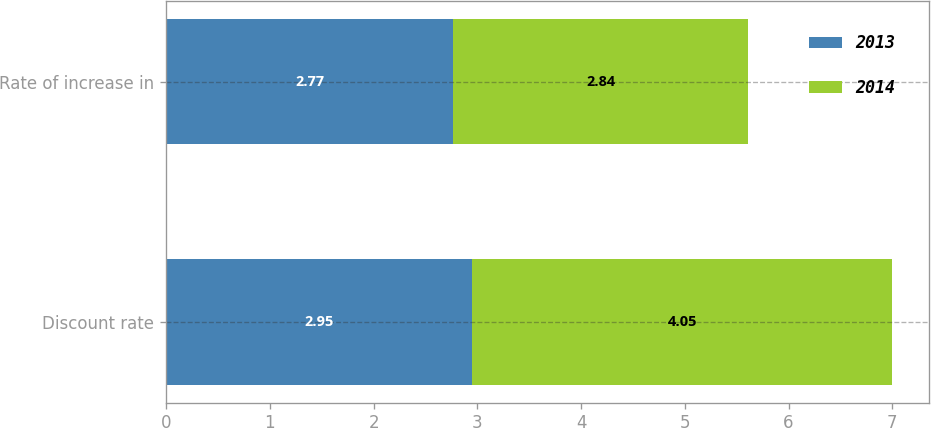Convert chart to OTSL. <chart><loc_0><loc_0><loc_500><loc_500><stacked_bar_chart><ecel><fcel>Discount rate<fcel>Rate of increase in<nl><fcel>2013<fcel>2.95<fcel>2.77<nl><fcel>2014<fcel>4.05<fcel>2.84<nl></chart> 